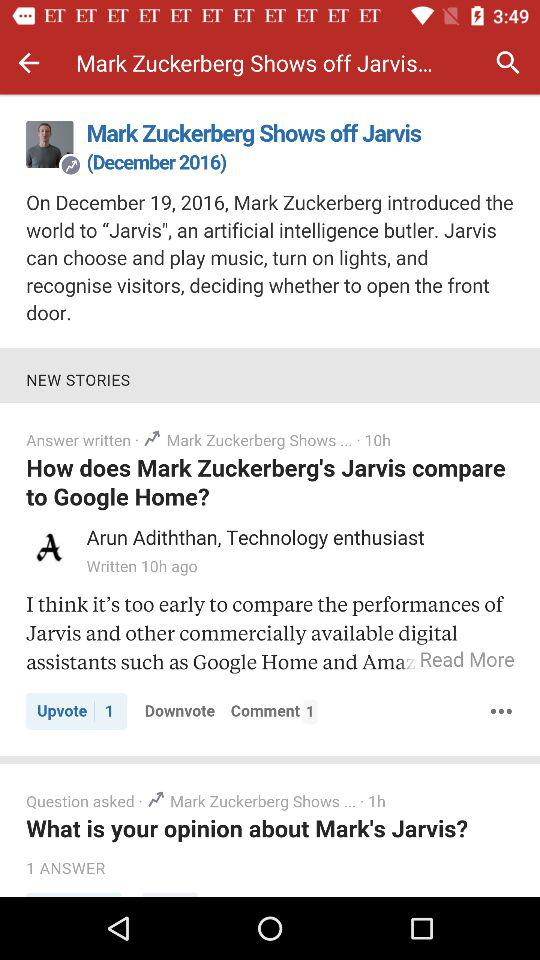How many more answers are there to the question about Jarvis than to the question about Mark's opinion of Jarvis?
Answer the question using a single word or phrase. 1 